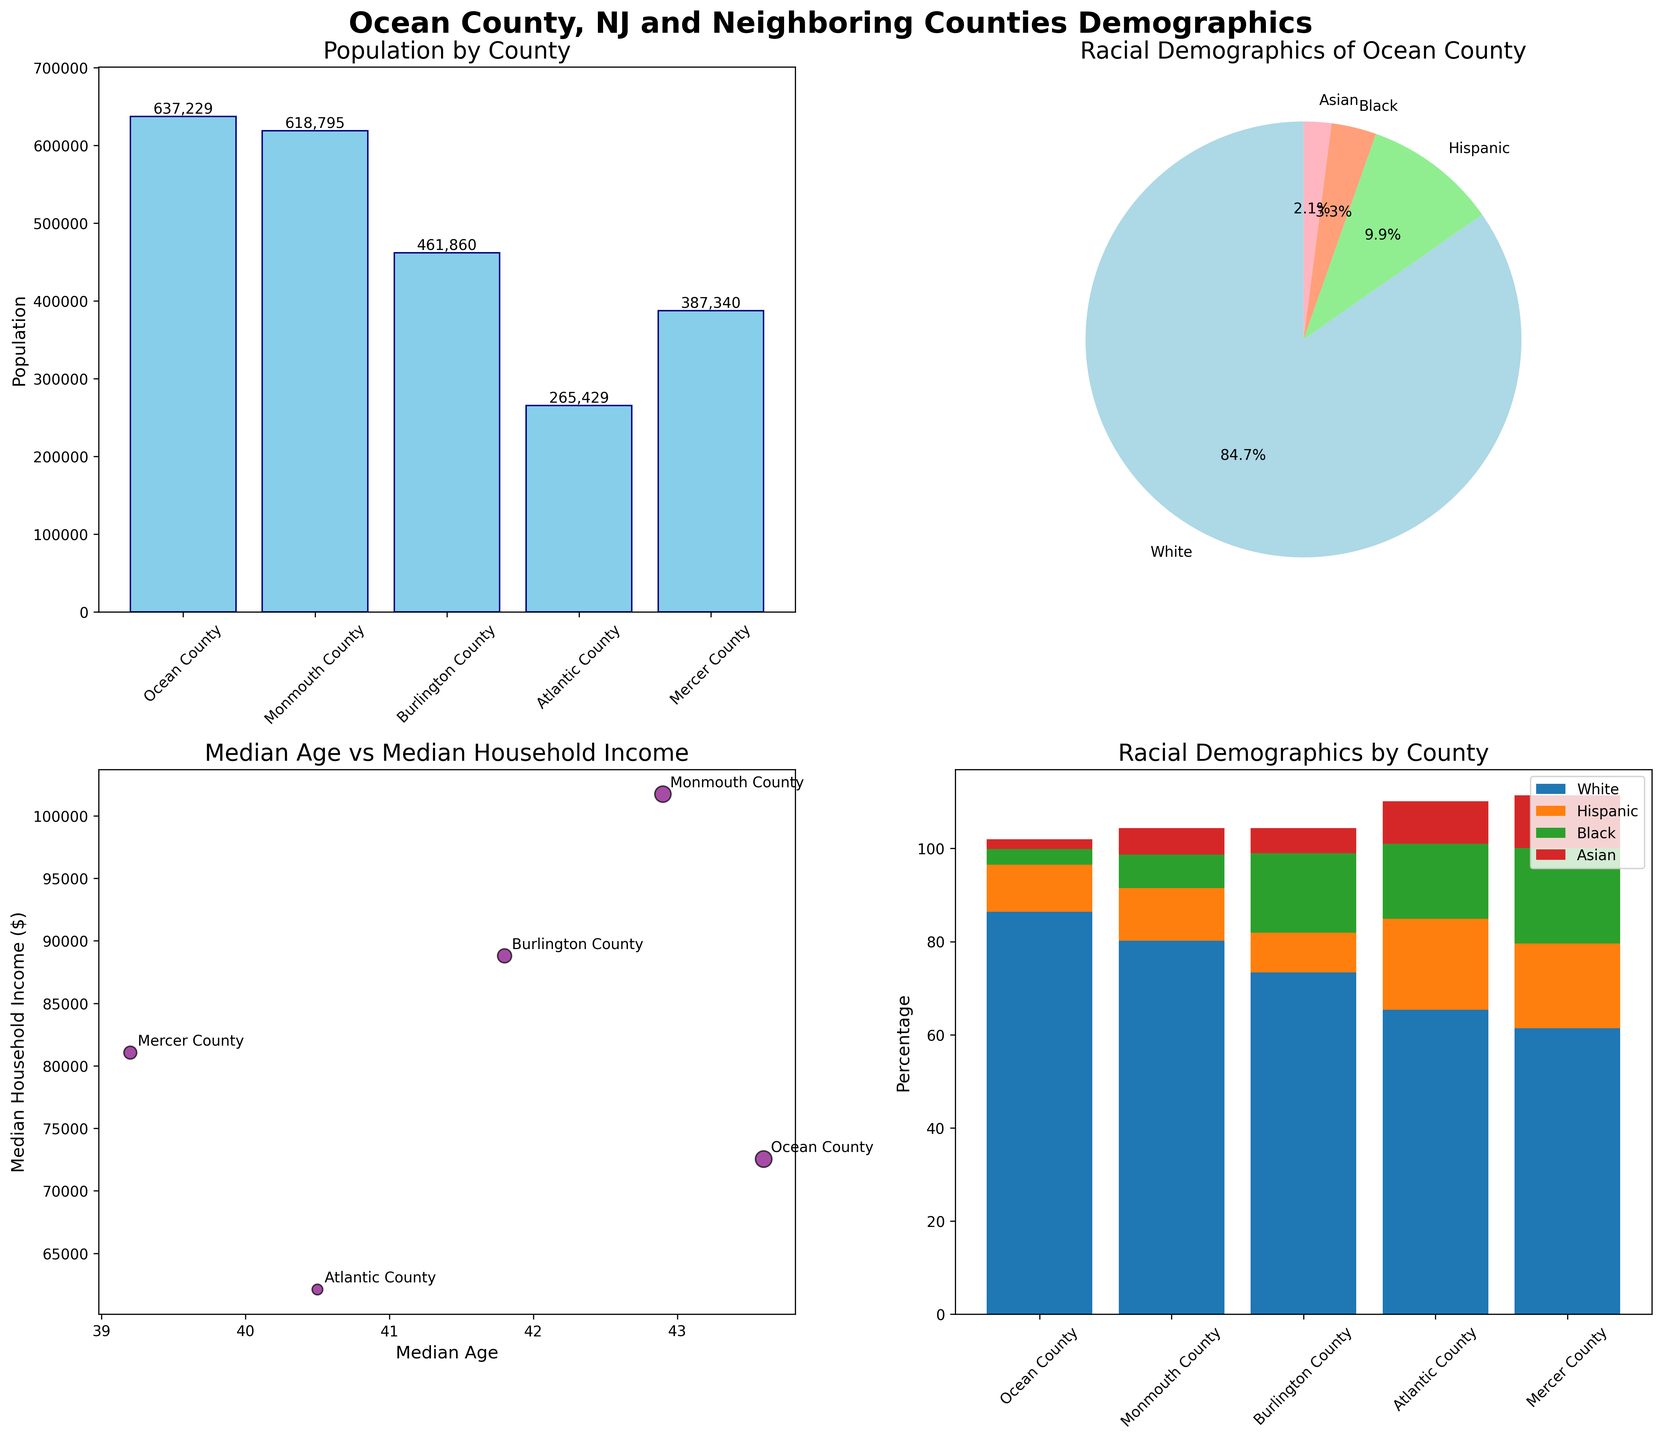What's the population of Ocean County? The bar chart titled "Population by County" shows the populations of the listed counties. Ocean County has a bar height representing its population. Reading off the value next to the bar, we see it is 637,229.
Answer: 637,229 Which county has the highest median household income? Check the scatter plot titled "Median Age vs Median Household Income." The y-axis represents median household income, noting which county's point is highest on this axis. Monmouth County has the highest median household income.
Answer: Monmouth County What percentage of Ocean County's population is Hispanic? The pie chart titled "Racial Demographics of Ocean County" shows slices representing different racial percentages. The 'Hispanic' slice shows a percentage of 10.1%.
Answer: 10.1% Among the listed counties, which one has the lowest percentage of white population? In the stacked bar chart titled "Racial Demographics by County," observe the lowest height of the 'White' section. Mercer County has the lowest percentage of white population at 61.4%.
Answer: Mercer County Compare the populations of Ocean County and Monmouth County, which one is greater and by how much? Refer to the bar chart titled "Population by County." Ocean County has a population of 637,229 and Monmouth County has 618,795. Subtracting these values, Ocean County has 18,434 more people.
Answer: Ocean County by 18,434 What are the median ages of the counties with the lowest and highest median household income? Check the scatter plot titled "Median Age vs Median Household Income." Monmouth County has the highest median household income and median age 42.9. Atlantic County has the lowest median household income and median age 40.5.
Answer: Monmouth County: 42.9, Atlantic County: 40.5 What is the total Asian population percentage across all counties? Look at the stacked bar chart and add up the 'Asian (%)' segments for each county: Ocean County (2.1), Monmouth County (5.7), Burlington County (5.4), Atlantic County (9.1), Mercer County (11.3). Summing these gives 33.6%.
Answer: 33.6% What is the median household income of a county with a median age of 41.8? Refer to the scatter plot titled "Median Age vs Median Household Income" to find the county with a median age of 41.8, which is Burlington County. Its median household income is shown as 88,797.
Answer: 88,797 Which racial group forms the largest percentage in Ocean County? The pie chart indicates the largest slice corresponds to the 'White' category, which is 86.4%.
Answer: White What is the range of median ages among the counties? Observing the scatter plot, the median ages range from the lowest in Mercer County at 39.2 to the highest in Ocean County at 43.6. The range is 43.6 - 39.2 = 4.4 years.
Answer: 4.4 years 